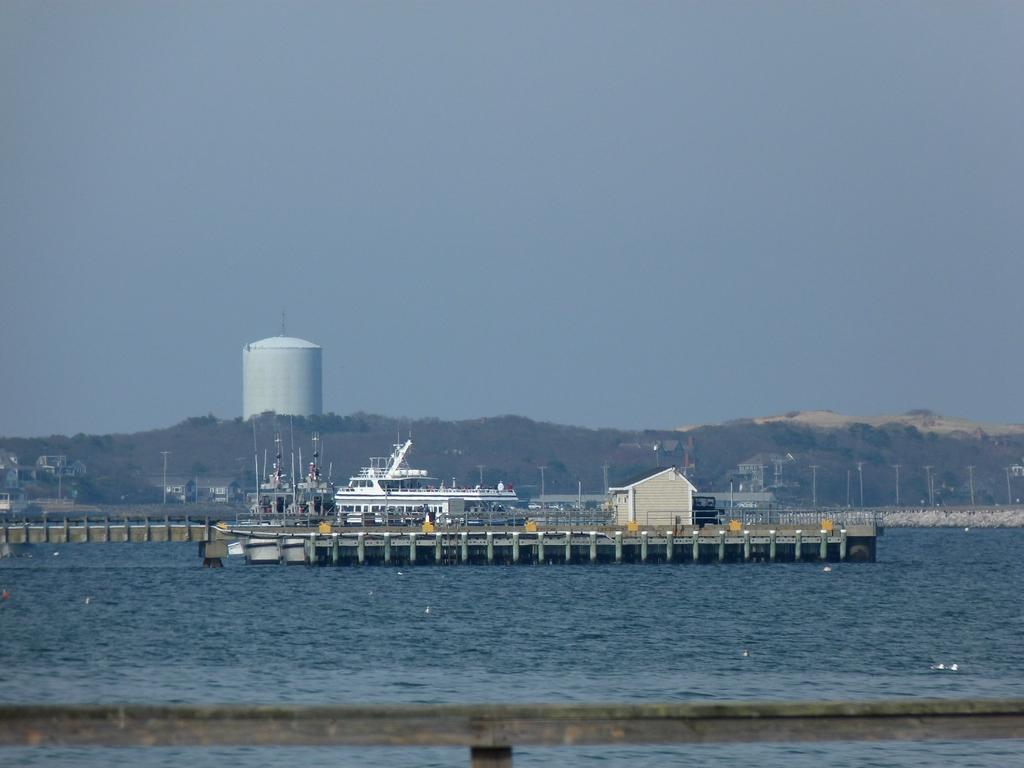What is the main subject of the image? The main subject of the image is a ship. What other structures or objects can be seen in the image? There is a platform, poles, houses, a fence, and a tank visible in the image. What type of natural feature is present in the image? There are mountains in the image. What is the setting of the image? The image features water, mountains, and a sky in the background, suggesting a coastal or lakeside setting. What is the purpose of the poles in the image? The purpose of the poles is not explicitly stated, but they could be used for mooring the ship or as part of a dock or pier. What type of lace can be seen hanging from the poles in the image? There is no lace present in the image, and therefore no such item can be seen hanging from the poles. 